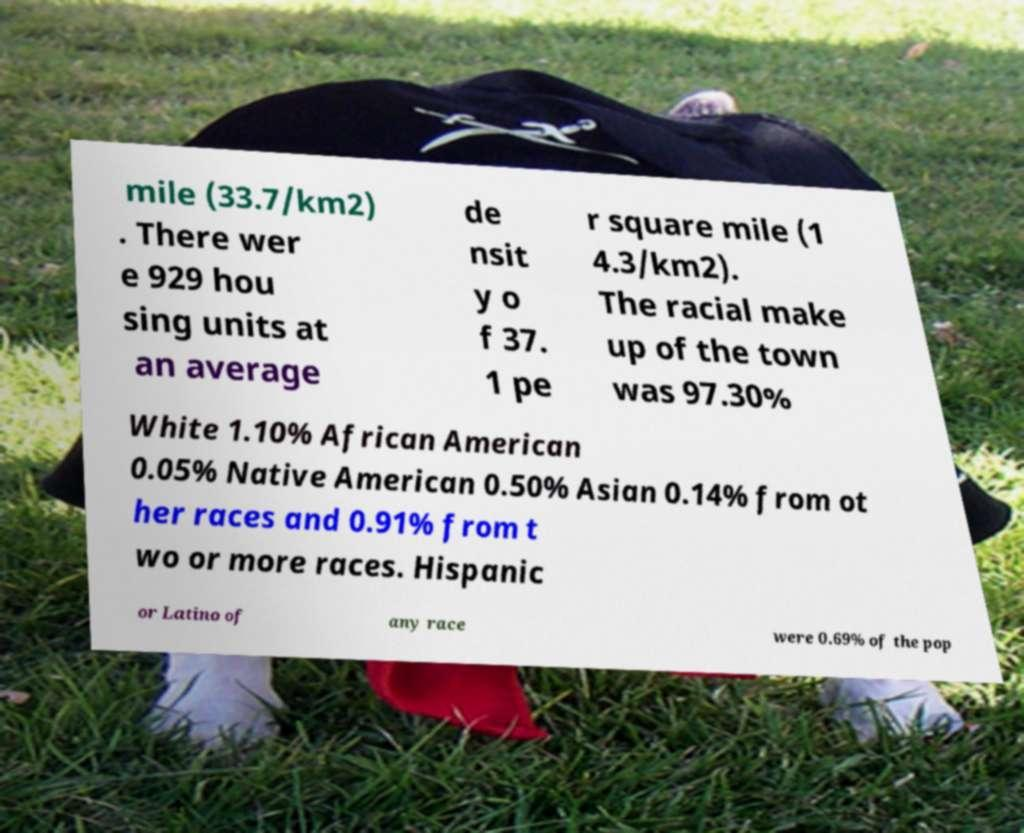For documentation purposes, I need the text within this image transcribed. Could you provide that? mile (33.7/km2) . There wer e 929 hou sing units at an average de nsit y o f 37. 1 pe r square mile (1 4.3/km2). The racial make up of the town was 97.30% White 1.10% African American 0.05% Native American 0.50% Asian 0.14% from ot her races and 0.91% from t wo or more races. Hispanic or Latino of any race were 0.69% of the pop 